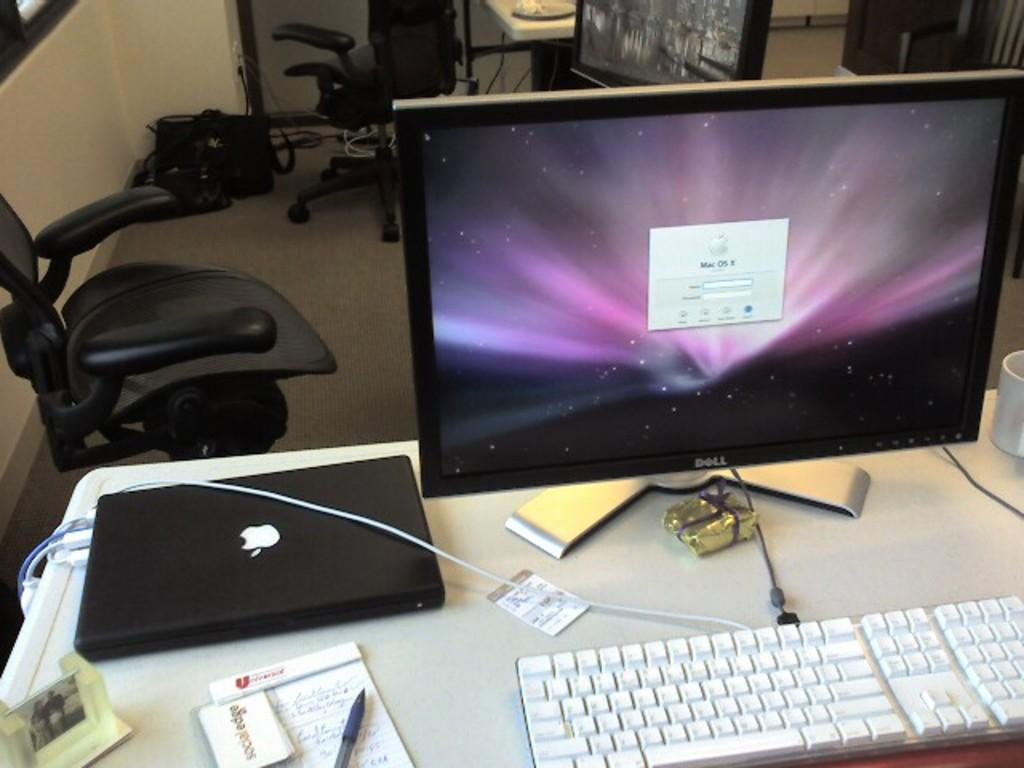<image>
Provide a brief description of the given image. An Apple computer sitting on a desk shows that it is running Mac OS X. 